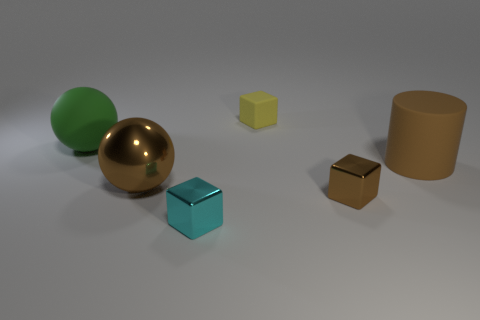Add 6 brown rubber things. How many brown rubber things exist? 7 Add 1 brown objects. How many objects exist? 7 Subtract all brown spheres. How many spheres are left? 1 Subtract all brown metallic cubes. How many cubes are left? 2 Subtract 0 yellow balls. How many objects are left? 6 Subtract all cylinders. How many objects are left? 5 Subtract 1 spheres. How many spheres are left? 1 Subtract all cyan blocks. Subtract all red cylinders. How many blocks are left? 2 Subtract all gray cylinders. How many cyan balls are left? 0 Subtract all gray rubber cylinders. Subtract all brown cylinders. How many objects are left? 5 